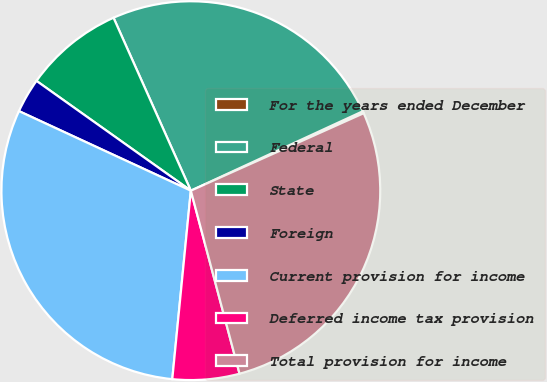<chart> <loc_0><loc_0><loc_500><loc_500><pie_chart><fcel>For the years ended December<fcel>Federal<fcel>State<fcel>Foreign<fcel>Current provision for income<fcel>Deferred income tax provision<fcel>Total provision for income<nl><fcel>0.18%<fcel>24.81%<fcel>8.47%<fcel>2.94%<fcel>30.34%<fcel>5.7%<fcel>27.57%<nl></chart> 